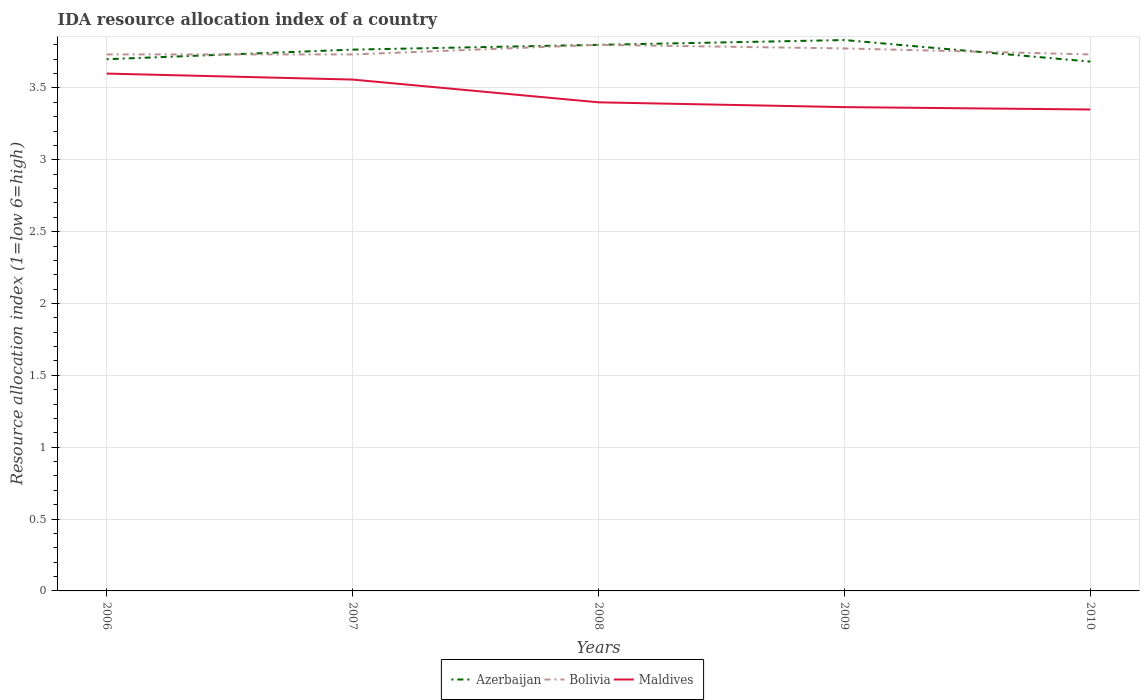Across all years, what is the maximum IDA resource allocation index in Bolivia?
Keep it short and to the point. 3.73. In which year was the IDA resource allocation index in Azerbaijan maximum?
Ensure brevity in your answer.  2010. What is the total IDA resource allocation index in Maldives in the graph?
Offer a terse response. 0.23. What is the difference between the highest and the second highest IDA resource allocation index in Maldives?
Provide a succinct answer. 0.25. What is the difference between the highest and the lowest IDA resource allocation index in Maldives?
Your answer should be very brief. 2. Is the IDA resource allocation index in Azerbaijan strictly greater than the IDA resource allocation index in Bolivia over the years?
Ensure brevity in your answer.  No. How many lines are there?
Your response must be concise. 3. Does the graph contain any zero values?
Provide a short and direct response. No. Does the graph contain grids?
Make the answer very short. Yes. How are the legend labels stacked?
Provide a short and direct response. Horizontal. What is the title of the graph?
Offer a terse response. IDA resource allocation index of a country. Does "Morocco" appear as one of the legend labels in the graph?
Offer a very short reply. No. What is the label or title of the Y-axis?
Keep it short and to the point. Resource allocation index (1=low 6=high). What is the Resource allocation index (1=low 6=high) of Azerbaijan in 2006?
Make the answer very short. 3.7. What is the Resource allocation index (1=low 6=high) of Bolivia in 2006?
Give a very brief answer. 3.73. What is the Resource allocation index (1=low 6=high) in Maldives in 2006?
Give a very brief answer. 3.6. What is the Resource allocation index (1=low 6=high) of Azerbaijan in 2007?
Offer a very short reply. 3.77. What is the Resource allocation index (1=low 6=high) in Bolivia in 2007?
Make the answer very short. 3.73. What is the Resource allocation index (1=low 6=high) of Maldives in 2007?
Offer a very short reply. 3.56. What is the Resource allocation index (1=low 6=high) in Maldives in 2008?
Make the answer very short. 3.4. What is the Resource allocation index (1=low 6=high) in Azerbaijan in 2009?
Provide a succinct answer. 3.83. What is the Resource allocation index (1=low 6=high) in Bolivia in 2009?
Offer a very short reply. 3.77. What is the Resource allocation index (1=low 6=high) in Maldives in 2009?
Provide a succinct answer. 3.37. What is the Resource allocation index (1=low 6=high) in Azerbaijan in 2010?
Offer a terse response. 3.68. What is the Resource allocation index (1=low 6=high) in Bolivia in 2010?
Give a very brief answer. 3.73. What is the Resource allocation index (1=low 6=high) of Maldives in 2010?
Your response must be concise. 3.35. Across all years, what is the maximum Resource allocation index (1=low 6=high) in Azerbaijan?
Make the answer very short. 3.83. Across all years, what is the minimum Resource allocation index (1=low 6=high) of Azerbaijan?
Offer a terse response. 3.68. Across all years, what is the minimum Resource allocation index (1=low 6=high) of Bolivia?
Ensure brevity in your answer.  3.73. Across all years, what is the minimum Resource allocation index (1=low 6=high) in Maldives?
Keep it short and to the point. 3.35. What is the total Resource allocation index (1=low 6=high) in Azerbaijan in the graph?
Make the answer very short. 18.78. What is the total Resource allocation index (1=low 6=high) in Bolivia in the graph?
Offer a very short reply. 18.77. What is the total Resource allocation index (1=low 6=high) of Maldives in the graph?
Offer a terse response. 17.27. What is the difference between the Resource allocation index (1=low 6=high) of Azerbaijan in 2006 and that in 2007?
Provide a short and direct response. -0.07. What is the difference between the Resource allocation index (1=low 6=high) in Bolivia in 2006 and that in 2007?
Ensure brevity in your answer.  0. What is the difference between the Resource allocation index (1=low 6=high) of Maldives in 2006 and that in 2007?
Offer a terse response. 0.04. What is the difference between the Resource allocation index (1=low 6=high) of Azerbaijan in 2006 and that in 2008?
Offer a very short reply. -0.1. What is the difference between the Resource allocation index (1=low 6=high) of Bolivia in 2006 and that in 2008?
Provide a succinct answer. -0.07. What is the difference between the Resource allocation index (1=low 6=high) in Azerbaijan in 2006 and that in 2009?
Ensure brevity in your answer.  -0.13. What is the difference between the Resource allocation index (1=low 6=high) of Bolivia in 2006 and that in 2009?
Your response must be concise. -0.04. What is the difference between the Resource allocation index (1=low 6=high) in Maldives in 2006 and that in 2009?
Your response must be concise. 0.23. What is the difference between the Resource allocation index (1=low 6=high) of Azerbaijan in 2006 and that in 2010?
Offer a very short reply. 0.02. What is the difference between the Resource allocation index (1=low 6=high) in Bolivia in 2006 and that in 2010?
Keep it short and to the point. 0. What is the difference between the Resource allocation index (1=low 6=high) in Azerbaijan in 2007 and that in 2008?
Your answer should be very brief. -0.03. What is the difference between the Resource allocation index (1=low 6=high) in Bolivia in 2007 and that in 2008?
Keep it short and to the point. -0.07. What is the difference between the Resource allocation index (1=low 6=high) of Maldives in 2007 and that in 2008?
Ensure brevity in your answer.  0.16. What is the difference between the Resource allocation index (1=low 6=high) of Azerbaijan in 2007 and that in 2009?
Give a very brief answer. -0.07. What is the difference between the Resource allocation index (1=low 6=high) in Bolivia in 2007 and that in 2009?
Offer a terse response. -0.04. What is the difference between the Resource allocation index (1=low 6=high) in Maldives in 2007 and that in 2009?
Provide a succinct answer. 0.19. What is the difference between the Resource allocation index (1=low 6=high) of Azerbaijan in 2007 and that in 2010?
Ensure brevity in your answer.  0.08. What is the difference between the Resource allocation index (1=low 6=high) of Maldives in 2007 and that in 2010?
Give a very brief answer. 0.21. What is the difference between the Resource allocation index (1=low 6=high) in Azerbaijan in 2008 and that in 2009?
Give a very brief answer. -0.03. What is the difference between the Resource allocation index (1=low 6=high) in Bolivia in 2008 and that in 2009?
Make the answer very short. 0.03. What is the difference between the Resource allocation index (1=low 6=high) of Maldives in 2008 and that in 2009?
Ensure brevity in your answer.  0.03. What is the difference between the Resource allocation index (1=low 6=high) in Azerbaijan in 2008 and that in 2010?
Keep it short and to the point. 0.12. What is the difference between the Resource allocation index (1=low 6=high) in Bolivia in 2008 and that in 2010?
Provide a short and direct response. 0.07. What is the difference between the Resource allocation index (1=low 6=high) in Maldives in 2008 and that in 2010?
Make the answer very short. 0.05. What is the difference between the Resource allocation index (1=low 6=high) in Azerbaijan in 2009 and that in 2010?
Offer a terse response. 0.15. What is the difference between the Resource allocation index (1=low 6=high) of Bolivia in 2009 and that in 2010?
Give a very brief answer. 0.04. What is the difference between the Resource allocation index (1=low 6=high) in Maldives in 2009 and that in 2010?
Offer a very short reply. 0.02. What is the difference between the Resource allocation index (1=low 6=high) of Azerbaijan in 2006 and the Resource allocation index (1=low 6=high) of Bolivia in 2007?
Make the answer very short. -0.03. What is the difference between the Resource allocation index (1=low 6=high) of Azerbaijan in 2006 and the Resource allocation index (1=low 6=high) of Maldives in 2007?
Provide a short and direct response. 0.14. What is the difference between the Resource allocation index (1=low 6=high) of Bolivia in 2006 and the Resource allocation index (1=low 6=high) of Maldives in 2007?
Offer a very short reply. 0.17. What is the difference between the Resource allocation index (1=low 6=high) in Azerbaijan in 2006 and the Resource allocation index (1=low 6=high) in Maldives in 2008?
Your response must be concise. 0.3. What is the difference between the Resource allocation index (1=low 6=high) in Bolivia in 2006 and the Resource allocation index (1=low 6=high) in Maldives in 2008?
Your response must be concise. 0.33. What is the difference between the Resource allocation index (1=low 6=high) of Azerbaijan in 2006 and the Resource allocation index (1=low 6=high) of Bolivia in 2009?
Offer a very short reply. -0.07. What is the difference between the Resource allocation index (1=low 6=high) of Azerbaijan in 2006 and the Resource allocation index (1=low 6=high) of Maldives in 2009?
Give a very brief answer. 0.33. What is the difference between the Resource allocation index (1=low 6=high) in Bolivia in 2006 and the Resource allocation index (1=low 6=high) in Maldives in 2009?
Give a very brief answer. 0.37. What is the difference between the Resource allocation index (1=low 6=high) of Azerbaijan in 2006 and the Resource allocation index (1=low 6=high) of Bolivia in 2010?
Offer a terse response. -0.03. What is the difference between the Resource allocation index (1=low 6=high) of Bolivia in 2006 and the Resource allocation index (1=low 6=high) of Maldives in 2010?
Your answer should be compact. 0.38. What is the difference between the Resource allocation index (1=low 6=high) in Azerbaijan in 2007 and the Resource allocation index (1=low 6=high) in Bolivia in 2008?
Make the answer very short. -0.03. What is the difference between the Resource allocation index (1=low 6=high) of Azerbaijan in 2007 and the Resource allocation index (1=low 6=high) of Maldives in 2008?
Give a very brief answer. 0.37. What is the difference between the Resource allocation index (1=low 6=high) in Azerbaijan in 2007 and the Resource allocation index (1=low 6=high) in Bolivia in 2009?
Make the answer very short. -0.01. What is the difference between the Resource allocation index (1=low 6=high) of Azerbaijan in 2007 and the Resource allocation index (1=low 6=high) of Maldives in 2009?
Keep it short and to the point. 0.4. What is the difference between the Resource allocation index (1=low 6=high) of Bolivia in 2007 and the Resource allocation index (1=low 6=high) of Maldives in 2009?
Your answer should be compact. 0.37. What is the difference between the Resource allocation index (1=low 6=high) in Azerbaijan in 2007 and the Resource allocation index (1=low 6=high) in Bolivia in 2010?
Provide a succinct answer. 0.03. What is the difference between the Resource allocation index (1=low 6=high) in Azerbaijan in 2007 and the Resource allocation index (1=low 6=high) in Maldives in 2010?
Your response must be concise. 0.42. What is the difference between the Resource allocation index (1=low 6=high) of Bolivia in 2007 and the Resource allocation index (1=low 6=high) of Maldives in 2010?
Provide a short and direct response. 0.38. What is the difference between the Resource allocation index (1=low 6=high) of Azerbaijan in 2008 and the Resource allocation index (1=low 6=high) of Bolivia in 2009?
Ensure brevity in your answer.  0.03. What is the difference between the Resource allocation index (1=low 6=high) in Azerbaijan in 2008 and the Resource allocation index (1=low 6=high) in Maldives in 2009?
Offer a terse response. 0.43. What is the difference between the Resource allocation index (1=low 6=high) of Bolivia in 2008 and the Resource allocation index (1=low 6=high) of Maldives in 2009?
Offer a terse response. 0.43. What is the difference between the Resource allocation index (1=low 6=high) in Azerbaijan in 2008 and the Resource allocation index (1=low 6=high) in Bolivia in 2010?
Provide a succinct answer. 0.07. What is the difference between the Resource allocation index (1=low 6=high) of Azerbaijan in 2008 and the Resource allocation index (1=low 6=high) of Maldives in 2010?
Make the answer very short. 0.45. What is the difference between the Resource allocation index (1=low 6=high) of Bolivia in 2008 and the Resource allocation index (1=low 6=high) of Maldives in 2010?
Ensure brevity in your answer.  0.45. What is the difference between the Resource allocation index (1=low 6=high) of Azerbaijan in 2009 and the Resource allocation index (1=low 6=high) of Maldives in 2010?
Make the answer very short. 0.48. What is the difference between the Resource allocation index (1=low 6=high) of Bolivia in 2009 and the Resource allocation index (1=low 6=high) of Maldives in 2010?
Your answer should be compact. 0.42. What is the average Resource allocation index (1=low 6=high) in Azerbaijan per year?
Your response must be concise. 3.76. What is the average Resource allocation index (1=low 6=high) of Bolivia per year?
Keep it short and to the point. 3.75. What is the average Resource allocation index (1=low 6=high) in Maldives per year?
Give a very brief answer. 3.46. In the year 2006, what is the difference between the Resource allocation index (1=low 6=high) of Azerbaijan and Resource allocation index (1=low 6=high) of Bolivia?
Keep it short and to the point. -0.03. In the year 2006, what is the difference between the Resource allocation index (1=low 6=high) in Azerbaijan and Resource allocation index (1=low 6=high) in Maldives?
Provide a succinct answer. 0.1. In the year 2006, what is the difference between the Resource allocation index (1=low 6=high) of Bolivia and Resource allocation index (1=low 6=high) of Maldives?
Provide a succinct answer. 0.13. In the year 2007, what is the difference between the Resource allocation index (1=low 6=high) in Azerbaijan and Resource allocation index (1=low 6=high) in Bolivia?
Your answer should be compact. 0.03. In the year 2007, what is the difference between the Resource allocation index (1=low 6=high) of Azerbaijan and Resource allocation index (1=low 6=high) of Maldives?
Offer a terse response. 0.21. In the year 2007, what is the difference between the Resource allocation index (1=low 6=high) in Bolivia and Resource allocation index (1=low 6=high) in Maldives?
Provide a short and direct response. 0.17. In the year 2008, what is the difference between the Resource allocation index (1=low 6=high) in Azerbaijan and Resource allocation index (1=low 6=high) in Bolivia?
Keep it short and to the point. 0. In the year 2008, what is the difference between the Resource allocation index (1=low 6=high) in Azerbaijan and Resource allocation index (1=low 6=high) in Maldives?
Give a very brief answer. 0.4. In the year 2009, what is the difference between the Resource allocation index (1=low 6=high) of Azerbaijan and Resource allocation index (1=low 6=high) of Bolivia?
Make the answer very short. 0.06. In the year 2009, what is the difference between the Resource allocation index (1=low 6=high) of Azerbaijan and Resource allocation index (1=low 6=high) of Maldives?
Offer a very short reply. 0.47. In the year 2009, what is the difference between the Resource allocation index (1=low 6=high) of Bolivia and Resource allocation index (1=low 6=high) of Maldives?
Your response must be concise. 0.41. In the year 2010, what is the difference between the Resource allocation index (1=low 6=high) of Azerbaijan and Resource allocation index (1=low 6=high) of Bolivia?
Ensure brevity in your answer.  -0.05. In the year 2010, what is the difference between the Resource allocation index (1=low 6=high) in Azerbaijan and Resource allocation index (1=low 6=high) in Maldives?
Make the answer very short. 0.33. In the year 2010, what is the difference between the Resource allocation index (1=low 6=high) in Bolivia and Resource allocation index (1=low 6=high) in Maldives?
Provide a short and direct response. 0.38. What is the ratio of the Resource allocation index (1=low 6=high) in Azerbaijan in 2006 to that in 2007?
Your answer should be very brief. 0.98. What is the ratio of the Resource allocation index (1=low 6=high) of Maldives in 2006 to that in 2007?
Give a very brief answer. 1.01. What is the ratio of the Resource allocation index (1=low 6=high) of Azerbaijan in 2006 to that in 2008?
Offer a very short reply. 0.97. What is the ratio of the Resource allocation index (1=low 6=high) in Bolivia in 2006 to that in 2008?
Your answer should be compact. 0.98. What is the ratio of the Resource allocation index (1=low 6=high) of Maldives in 2006 to that in 2008?
Make the answer very short. 1.06. What is the ratio of the Resource allocation index (1=low 6=high) in Azerbaijan in 2006 to that in 2009?
Your response must be concise. 0.97. What is the ratio of the Resource allocation index (1=low 6=high) of Bolivia in 2006 to that in 2009?
Ensure brevity in your answer.  0.99. What is the ratio of the Resource allocation index (1=low 6=high) of Maldives in 2006 to that in 2009?
Provide a succinct answer. 1.07. What is the ratio of the Resource allocation index (1=low 6=high) of Bolivia in 2006 to that in 2010?
Your response must be concise. 1. What is the ratio of the Resource allocation index (1=low 6=high) in Maldives in 2006 to that in 2010?
Your answer should be very brief. 1.07. What is the ratio of the Resource allocation index (1=low 6=high) of Azerbaijan in 2007 to that in 2008?
Ensure brevity in your answer.  0.99. What is the ratio of the Resource allocation index (1=low 6=high) in Bolivia in 2007 to that in 2008?
Your answer should be very brief. 0.98. What is the ratio of the Resource allocation index (1=low 6=high) in Maldives in 2007 to that in 2008?
Your response must be concise. 1.05. What is the ratio of the Resource allocation index (1=low 6=high) in Azerbaijan in 2007 to that in 2009?
Keep it short and to the point. 0.98. What is the ratio of the Resource allocation index (1=low 6=high) in Maldives in 2007 to that in 2009?
Your answer should be compact. 1.06. What is the ratio of the Resource allocation index (1=low 6=high) in Azerbaijan in 2007 to that in 2010?
Your answer should be very brief. 1.02. What is the ratio of the Resource allocation index (1=low 6=high) in Bolivia in 2007 to that in 2010?
Your response must be concise. 1. What is the ratio of the Resource allocation index (1=low 6=high) in Maldives in 2007 to that in 2010?
Your answer should be compact. 1.06. What is the ratio of the Resource allocation index (1=low 6=high) of Azerbaijan in 2008 to that in 2009?
Provide a succinct answer. 0.99. What is the ratio of the Resource allocation index (1=low 6=high) in Bolivia in 2008 to that in 2009?
Ensure brevity in your answer.  1.01. What is the ratio of the Resource allocation index (1=low 6=high) of Maldives in 2008 to that in 2009?
Your answer should be very brief. 1.01. What is the ratio of the Resource allocation index (1=low 6=high) in Azerbaijan in 2008 to that in 2010?
Ensure brevity in your answer.  1.03. What is the ratio of the Resource allocation index (1=low 6=high) of Bolivia in 2008 to that in 2010?
Give a very brief answer. 1.02. What is the ratio of the Resource allocation index (1=low 6=high) of Maldives in 2008 to that in 2010?
Provide a succinct answer. 1.01. What is the ratio of the Resource allocation index (1=low 6=high) of Azerbaijan in 2009 to that in 2010?
Ensure brevity in your answer.  1.04. What is the ratio of the Resource allocation index (1=low 6=high) in Bolivia in 2009 to that in 2010?
Offer a terse response. 1.01. What is the ratio of the Resource allocation index (1=low 6=high) in Maldives in 2009 to that in 2010?
Your answer should be very brief. 1. What is the difference between the highest and the second highest Resource allocation index (1=low 6=high) in Bolivia?
Keep it short and to the point. 0.03. What is the difference between the highest and the second highest Resource allocation index (1=low 6=high) of Maldives?
Provide a succinct answer. 0.04. What is the difference between the highest and the lowest Resource allocation index (1=low 6=high) in Bolivia?
Keep it short and to the point. 0.07. 